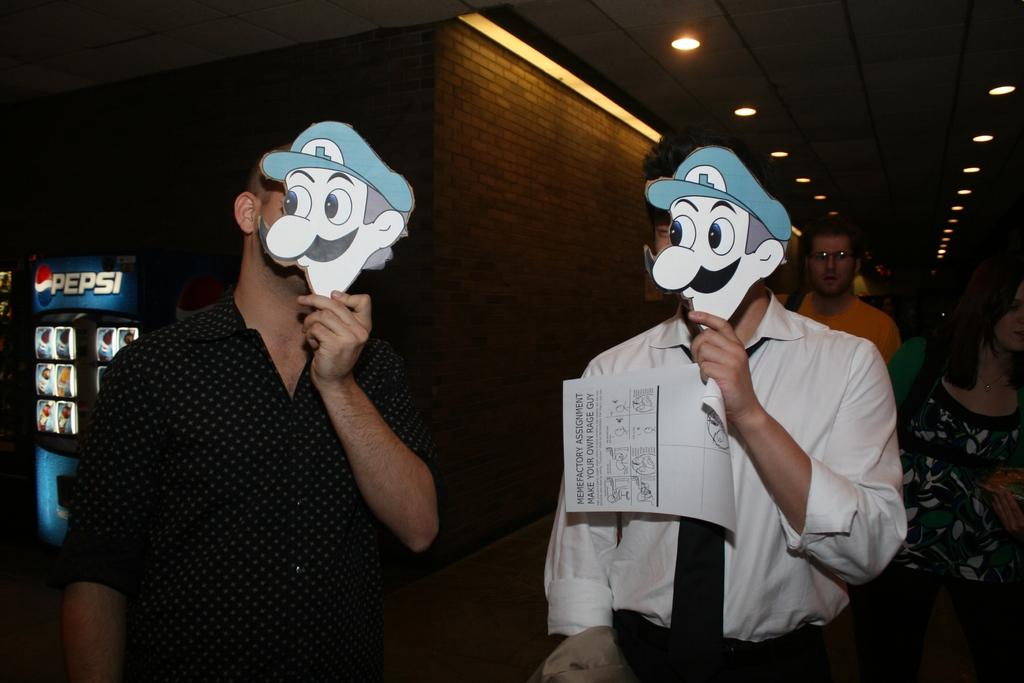How many women are in the image? There are two women in the image. What are the women holding in the image? The women are holding masks in the image. What else can be seen in the image besides the women and masks? There is a paper, a fridge, a wall, and lights visible in the image. How many people are present in the image? There are a few persons in the image. What type of toys can be seen on the neck of one of the women in the image? There are no toys visible in the image, and no indication that any of the women are wearing anything around their necks. 